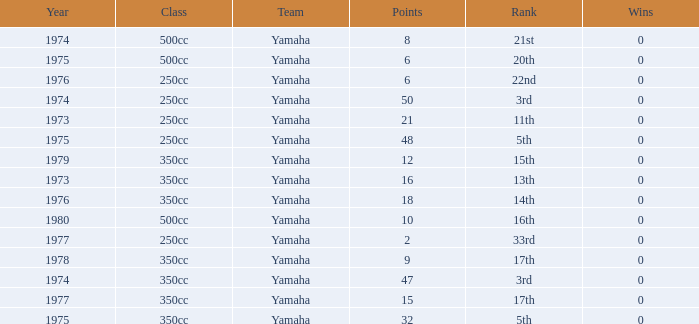How many Points have a Rank of 17th, and Wins larger than 0? 0.0. 